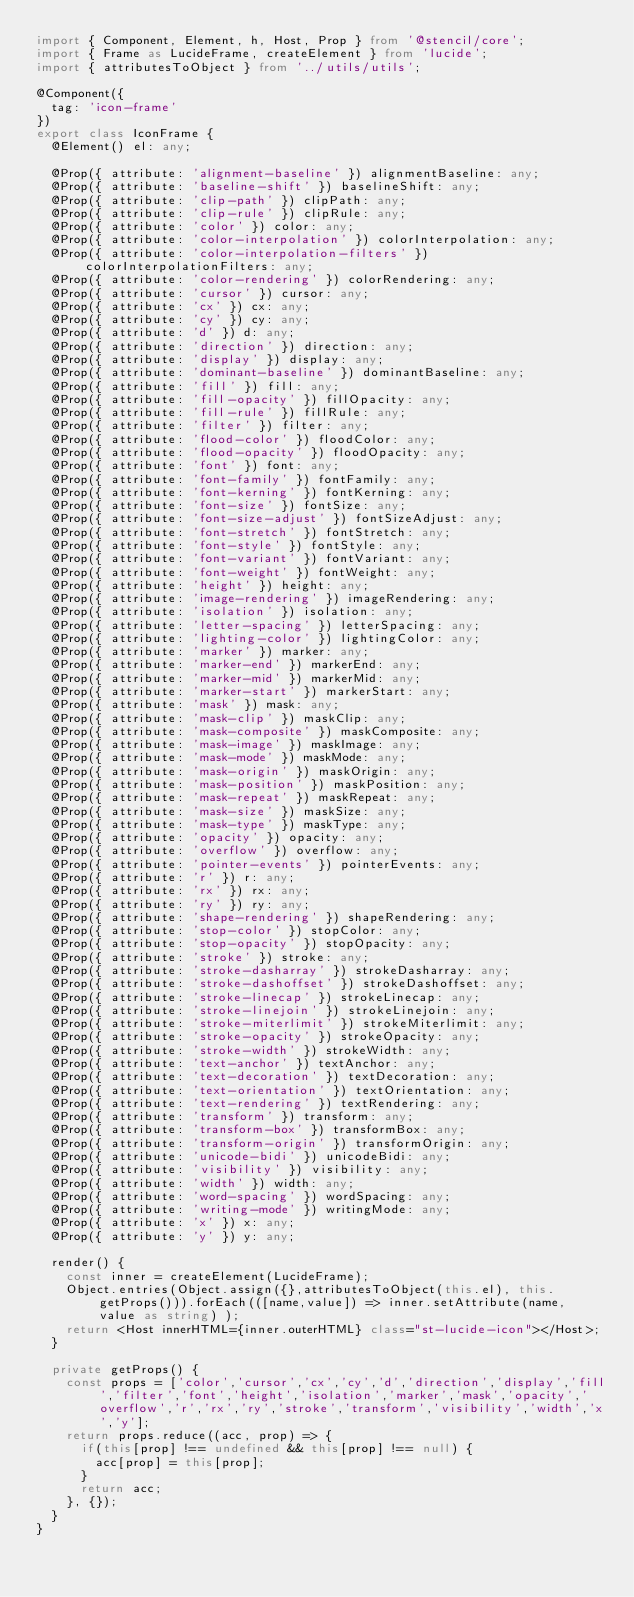<code> <loc_0><loc_0><loc_500><loc_500><_TypeScript_>import { Component, Element, h, Host, Prop } from '@stencil/core';
import { Frame as LucideFrame, createElement } from 'lucide';
import { attributesToObject } from '../utils/utils';

@Component({
  tag: 'icon-frame'
})
export class IconFrame {
  @Element() el: any;

  @Prop({ attribute: 'alignment-baseline' }) alignmentBaseline: any;
  @Prop({ attribute: 'baseline-shift' }) baselineShift: any;
  @Prop({ attribute: 'clip-path' }) clipPath: any;
  @Prop({ attribute: 'clip-rule' }) clipRule: any;
  @Prop({ attribute: 'color' }) color: any;
  @Prop({ attribute: 'color-interpolation' }) colorInterpolation: any;
  @Prop({ attribute: 'color-interpolation-filters' }) colorInterpolationFilters: any;
  @Prop({ attribute: 'color-rendering' }) colorRendering: any;
  @Prop({ attribute: 'cursor' }) cursor: any;
  @Prop({ attribute: 'cx' }) cx: any;
  @Prop({ attribute: 'cy' }) cy: any;
  @Prop({ attribute: 'd' }) d: any;
  @Prop({ attribute: 'direction' }) direction: any;
  @Prop({ attribute: 'display' }) display: any;
  @Prop({ attribute: 'dominant-baseline' }) dominantBaseline: any;
  @Prop({ attribute: 'fill' }) fill: any;
  @Prop({ attribute: 'fill-opacity' }) fillOpacity: any;
  @Prop({ attribute: 'fill-rule' }) fillRule: any;
  @Prop({ attribute: 'filter' }) filter: any;
  @Prop({ attribute: 'flood-color' }) floodColor: any;
  @Prop({ attribute: 'flood-opacity' }) floodOpacity: any;
  @Prop({ attribute: 'font' }) font: any;
  @Prop({ attribute: 'font-family' }) fontFamily: any;
  @Prop({ attribute: 'font-kerning' }) fontKerning: any;
  @Prop({ attribute: 'font-size' }) fontSize: any;
  @Prop({ attribute: 'font-size-adjust' }) fontSizeAdjust: any;
  @Prop({ attribute: 'font-stretch' }) fontStretch: any;
  @Prop({ attribute: 'font-style' }) fontStyle: any;
  @Prop({ attribute: 'font-variant' }) fontVariant: any;
  @Prop({ attribute: 'font-weight' }) fontWeight: any;
  @Prop({ attribute: 'height' }) height: any;
  @Prop({ attribute: 'image-rendering' }) imageRendering: any;
  @Prop({ attribute: 'isolation' }) isolation: any;
  @Prop({ attribute: 'letter-spacing' }) letterSpacing: any;
  @Prop({ attribute: 'lighting-color' }) lightingColor: any;
  @Prop({ attribute: 'marker' }) marker: any;
  @Prop({ attribute: 'marker-end' }) markerEnd: any;
  @Prop({ attribute: 'marker-mid' }) markerMid: any;
  @Prop({ attribute: 'marker-start' }) markerStart: any;
  @Prop({ attribute: 'mask' }) mask: any;
  @Prop({ attribute: 'mask-clip' }) maskClip: any;
  @Prop({ attribute: 'mask-composite' }) maskComposite: any;
  @Prop({ attribute: 'mask-image' }) maskImage: any;
  @Prop({ attribute: 'mask-mode' }) maskMode: any;
  @Prop({ attribute: 'mask-origin' }) maskOrigin: any;
  @Prop({ attribute: 'mask-position' }) maskPosition: any;
  @Prop({ attribute: 'mask-repeat' }) maskRepeat: any;
  @Prop({ attribute: 'mask-size' }) maskSize: any;
  @Prop({ attribute: 'mask-type' }) maskType: any;
  @Prop({ attribute: 'opacity' }) opacity: any;
  @Prop({ attribute: 'overflow' }) overflow: any;
  @Prop({ attribute: 'pointer-events' }) pointerEvents: any;
  @Prop({ attribute: 'r' }) r: any;
  @Prop({ attribute: 'rx' }) rx: any;
  @Prop({ attribute: 'ry' }) ry: any;
  @Prop({ attribute: 'shape-rendering' }) shapeRendering: any;
  @Prop({ attribute: 'stop-color' }) stopColor: any;
  @Prop({ attribute: 'stop-opacity' }) stopOpacity: any;
  @Prop({ attribute: 'stroke' }) stroke: any;
  @Prop({ attribute: 'stroke-dasharray' }) strokeDasharray: any;
  @Prop({ attribute: 'stroke-dashoffset' }) strokeDashoffset: any;
  @Prop({ attribute: 'stroke-linecap' }) strokeLinecap: any;
  @Prop({ attribute: 'stroke-linejoin' }) strokeLinejoin: any;
  @Prop({ attribute: 'stroke-miterlimit' }) strokeMiterlimit: any;
  @Prop({ attribute: 'stroke-opacity' }) strokeOpacity: any;
  @Prop({ attribute: 'stroke-width' }) strokeWidth: any;
  @Prop({ attribute: 'text-anchor' }) textAnchor: any;
  @Prop({ attribute: 'text-decoration' }) textDecoration: any;
  @Prop({ attribute: 'text-orientation' }) textOrientation: any;
  @Prop({ attribute: 'text-rendering' }) textRendering: any;
  @Prop({ attribute: 'transform' }) transform: any;
  @Prop({ attribute: 'transform-box' }) transformBox: any;
  @Prop({ attribute: 'transform-origin' }) transformOrigin: any;
  @Prop({ attribute: 'unicode-bidi' }) unicodeBidi: any;
  @Prop({ attribute: 'visibility' }) visibility: any;
  @Prop({ attribute: 'width' }) width: any;
  @Prop({ attribute: 'word-spacing' }) wordSpacing: any;
  @Prop({ attribute: 'writing-mode' }) writingMode: any;
  @Prop({ attribute: 'x' }) x: any;
  @Prop({ attribute: 'y' }) y: any;

  render() {
    const inner = createElement(LucideFrame);
    Object.entries(Object.assign({},attributesToObject(this.el), this.getProps())).forEach(([name,value]) => inner.setAttribute(name, value as string) );
    return <Host innerHTML={inner.outerHTML} class="st-lucide-icon"></Host>;
  }

  private getProps() {
    const props = ['color','cursor','cx','cy','d','direction','display','fill','filter','font','height','isolation','marker','mask','opacity','overflow','r','rx','ry','stroke','transform','visibility','width','x','y'];
    return props.reduce((acc, prop) => {
      if(this[prop] !== undefined && this[prop] !== null) {
        acc[prop] = this[prop];
      }
      return acc;
    }, {});
  }
}
</code> 